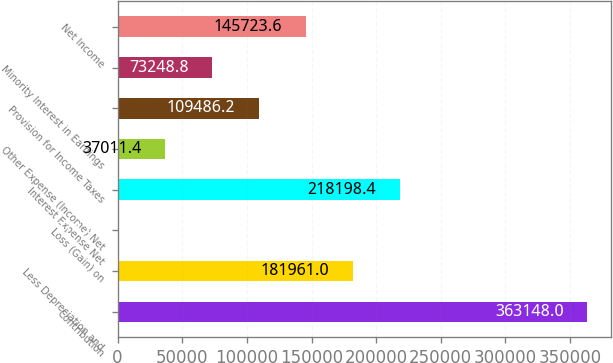Convert chart. <chart><loc_0><loc_0><loc_500><loc_500><bar_chart><fcel>Contribution<fcel>Less Depreciation and<fcel>Loss (Gain) on<fcel>Interest Expense Net<fcel>Other Expense (Income) Net<fcel>Provision for Income Taxes<fcel>Minority Interest in Earnings<fcel>Net Income<nl><fcel>363148<fcel>181961<fcel>774<fcel>218198<fcel>37011.4<fcel>109486<fcel>73248.8<fcel>145724<nl></chart> 